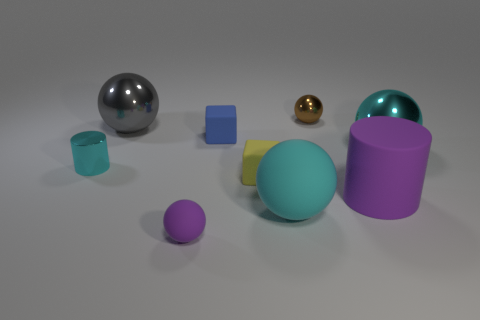Subtract all purple balls. How many balls are left? 4 Subtract all gray metallic spheres. How many spheres are left? 4 Add 1 large cyan rubber things. How many objects exist? 10 Subtract all yellow spheres. Subtract all purple blocks. How many spheres are left? 5 Subtract all cubes. How many objects are left? 7 Add 6 small purple rubber spheres. How many small purple rubber spheres exist? 7 Subtract 1 brown balls. How many objects are left? 8 Subtract all tiny purple matte balls. Subtract all big cyan shiny balls. How many objects are left? 7 Add 4 small yellow objects. How many small yellow objects are left? 5 